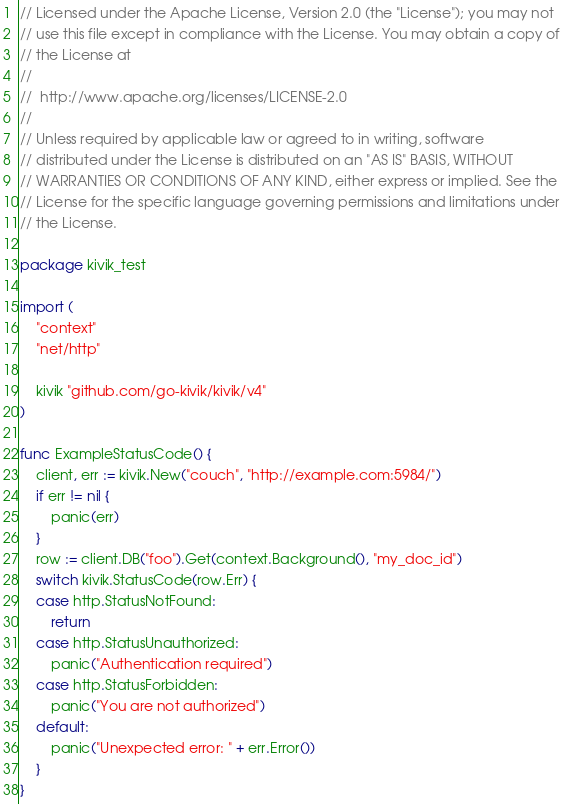<code> <loc_0><loc_0><loc_500><loc_500><_Go_>// Licensed under the Apache License, Version 2.0 (the "License"); you may not
// use this file except in compliance with the License. You may obtain a copy of
// the License at
//
//  http://www.apache.org/licenses/LICENSE-2.0
//
// Unless required by applicable law or agreed to in writing, software
// distributed under the License is distributed on an "AS IS" BASIS, WITHOUT
// WARRANTIES OR CONDITIONS OF ANY KIND, either express or implied. See the
// License for the specific language governing permissions and limitations under
// the License.

package kivik_test

import (
	"context"
	"net/http"

	kivik "github.com/go-kivik/kivik/v4"
)

func ExampleStatusCode() {
	client, err := kivik.New("couch", "http://example.com:5984/")
	if err != nil {
		panic(err)
	}
	row := client.DB("foo").Get(context.Background(), "my_doc_id")
	switch kivik.StatusCode(row.Err) {
	case http.StatusNotFound:
		return
	case http.StatusUnauthorized:
		panic("Authentication required")
	case http.StatusForbidden:
		panic("You are not authorized")
	default:
		panic("Unexpected error: " + err.Error())
	}
}
</code> 